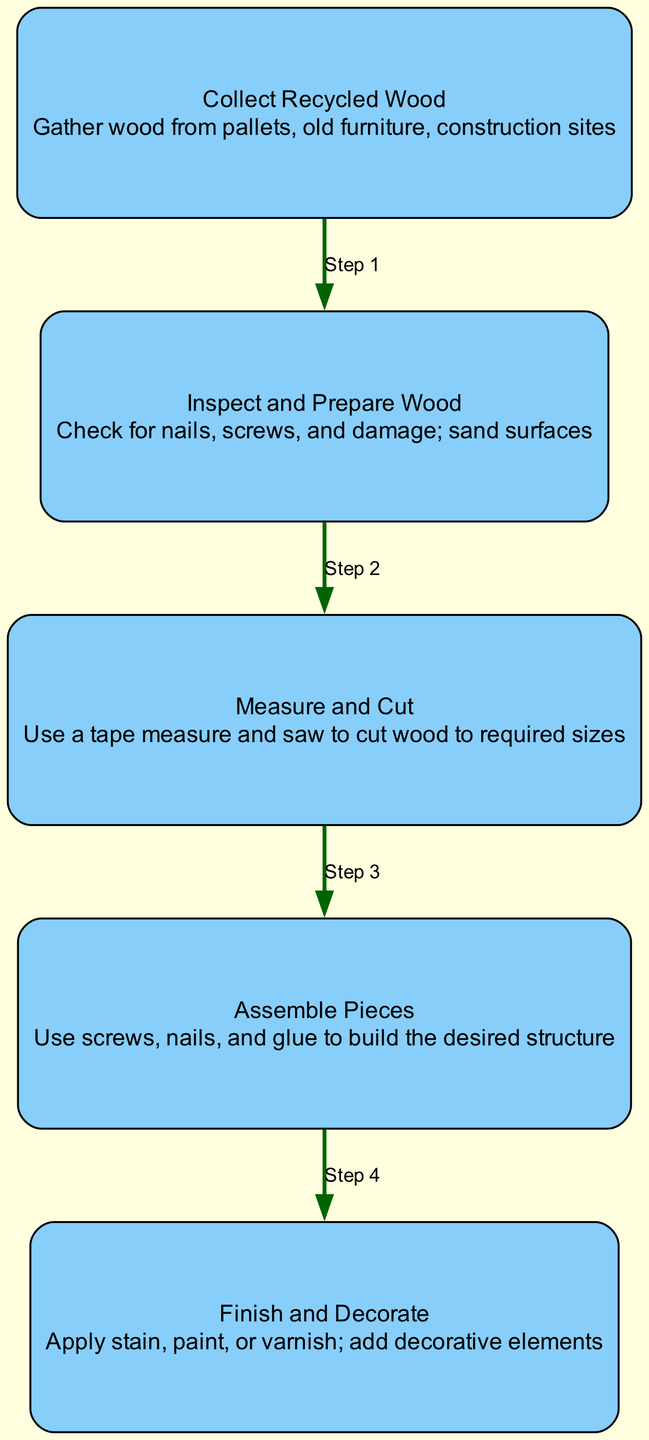What is the first step in the process? The first step is indicated by the directed edge leading from the "Collect Recycled Wood" node to the next node in the flow, showing it's the initial action to perform.
Answer: Collect Recycled Wood How many nodes are present in the diagram? By counting the unique nodes listed in the data, which represent distinct steps in the process, we find there are five nodes.
Answer: Five What do you do after inspecting the wood? Following the inspection step, the next action is represented by an edge leading to "Measure and Cut," indicating that measuring comes after inspecting.
Answer: Measure and Cut Which step involves applying stain or paint? The final action in the process, indicated as "Finish and Decorate," outlines applying decorative finishes, such as stain or paint, to the completed wood project.
Answer: Finish and Decorate What common element connects all steps? Each step is connected by edges that depict the flow from one action to the next, establishing the sequence in which these tasks must be completed.
Answer: Edges What is the role of the "Assemble Pieces" node? This node serves as a critical intermediate step where the already measured and cut wood is put together using screws, nails, and glue, making it vital for creating the structure.
Answer: Building the structure Which step directly follows measuring? Based on the flow depicted through the diagram, "Assemble Pieces" is the immediate subsequent action following "Measure and Cut."
Answer: Assemble Pieces What is the overall purpose of the diagram? The diagram is designed to convey a structured approach to using recycled wood for home decor projects, guiding users through each critical step.
Answer: Home decor projects 